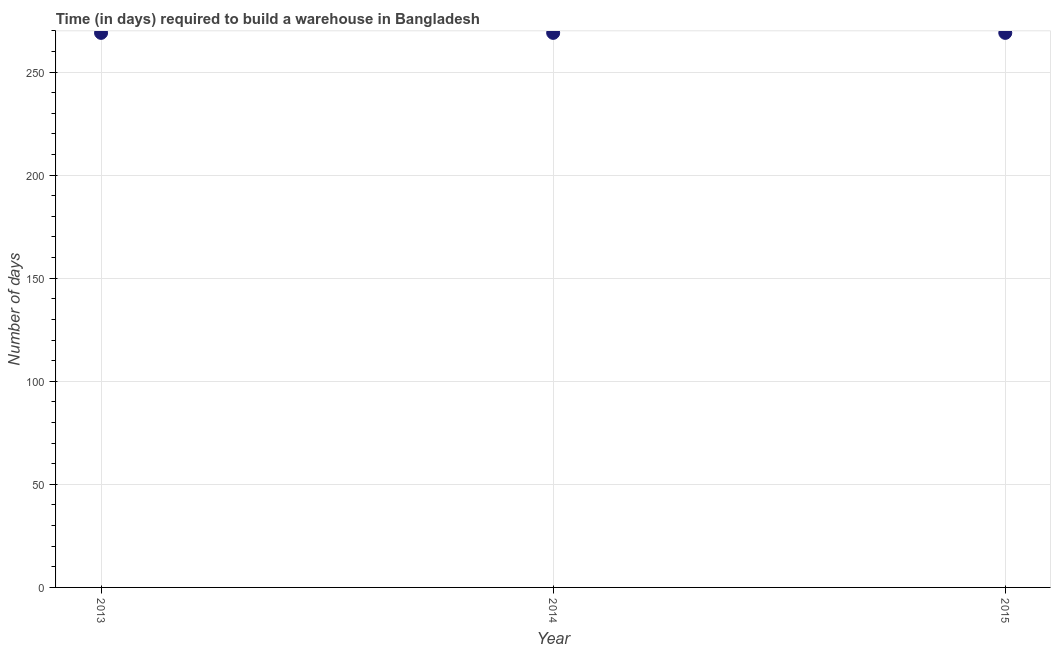What is the time required to build a warehouse in 2015?
Ensure brevity in your answer.  269. Across all years, what is the maximum time required to build a warehouse?
Your answer should be very brief. 269. Across all years, what is the minimum time required to build a warehouse?
Your answer should be very brief. 269. In which year was the time required to build a warehouse maximum?
Provide a succinct answer. 2013. What is the sum of the time required to build a warehouse?
Offer a terse response. 807. What is the average time required to build a warehouse per year?
Make the answer very short. 269. What is the median time required to build a warehouse?
Provide a short and direct response. 269. What is the ratio of the time required to build a warehouse in 2013 to that in 2014?
Your answer should be compact. 1. Is the time required to build a warehouse in 2013 less than that in 2015?
Offer a terse response. No. What is the difference between the highest and the lowest time required to build a warehouse?
Keep it short and to the point. 0. In how many years, is the time required to build a warehouse greater than the average time required to build a warehouse taken over all years?
Offer a very short reply. 0. How many dotlines are there?
Provide a succinct answer. 1. How many years are there in the graph?
Your answer should be very brief. 3. What is the difference between two consecutive major ticks on the Y-axis?
Your answer should be very brief. 50. Does the graph contain any zero values?
Ensure brevity in your answer.  No. What is the title of the graph?
Give a very brief answer. Time (in days) required to build a warehouse in Bangladesh. What is the label or title of the X-axis?
Your answer should be very brief. Year. What is the label or title of the Y-axis?
Your response must be concise. Number of days. What is the Number of days in 2013?
Your answer should be compact. 269. What is the Number of days in 2014?
Keep it short and to the point. 269. What is the Number of days in 2015?
Offer a very short reply. 269. What is the ratio of the Number of days in 2013 to that in 2015?
Provide a short and direct response. 1. What is the ratio of the Number of days in 2014 to that in 2015?
Your response must be concise. 1. 